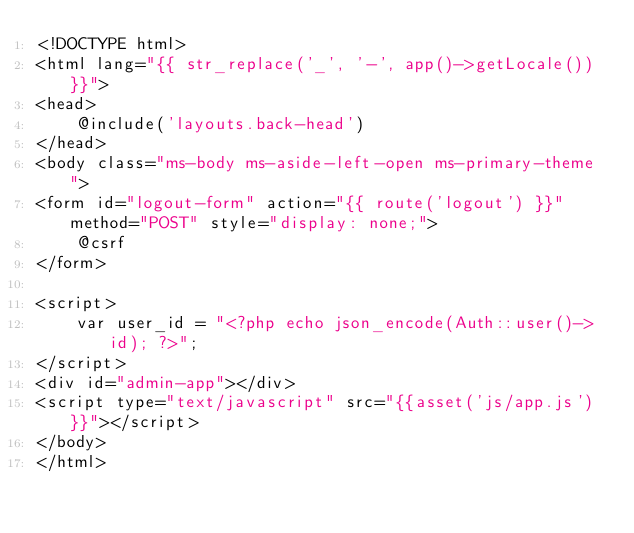Convert code to text. <code><loc_0><loc_0><loc_500><loc_500><_PHP_><!DOCTYPE html>
<html lang="{{ str_replace('_', '-', app()->getLocale()) }}">
<head>
	@include('layouts.back-head')
</head>
<body class="ms-body ms-aside-left-open ms-primary-theme ">
<form id="logout-form" action="{{ route('logout') }}" method="POST" style="display: none;">
	@csrf
</form>

<script>
	var user_id = "<?php echo json_encode(Auth::user()->id); ?>";
</script>
<div id="admin-app"></div>
<script type="text/javascript" src="{{asset('js/app.js')}}"></script>
</body>
</html>

</code> 